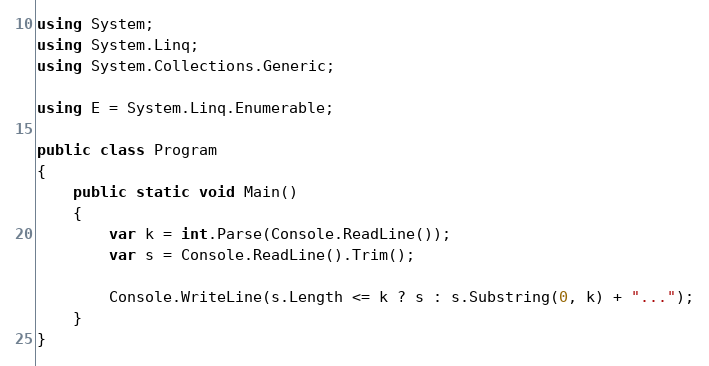<code> <loc_0><loc_0><loc_500><loc_500><_C#_>using System;
using System.Linq;
using System.Collections.Generic;

using E = System.Linq.Enumerable;

public class Program
{
    public static void Main()
    {
        var k = int.Parse(Console.ReadLine());
        var s = Console.ReadLine().Trim();

        Console.WriteLine(s.Length <= k ? s : s.Substring(0, k) + "...");
    }
}
</code> 